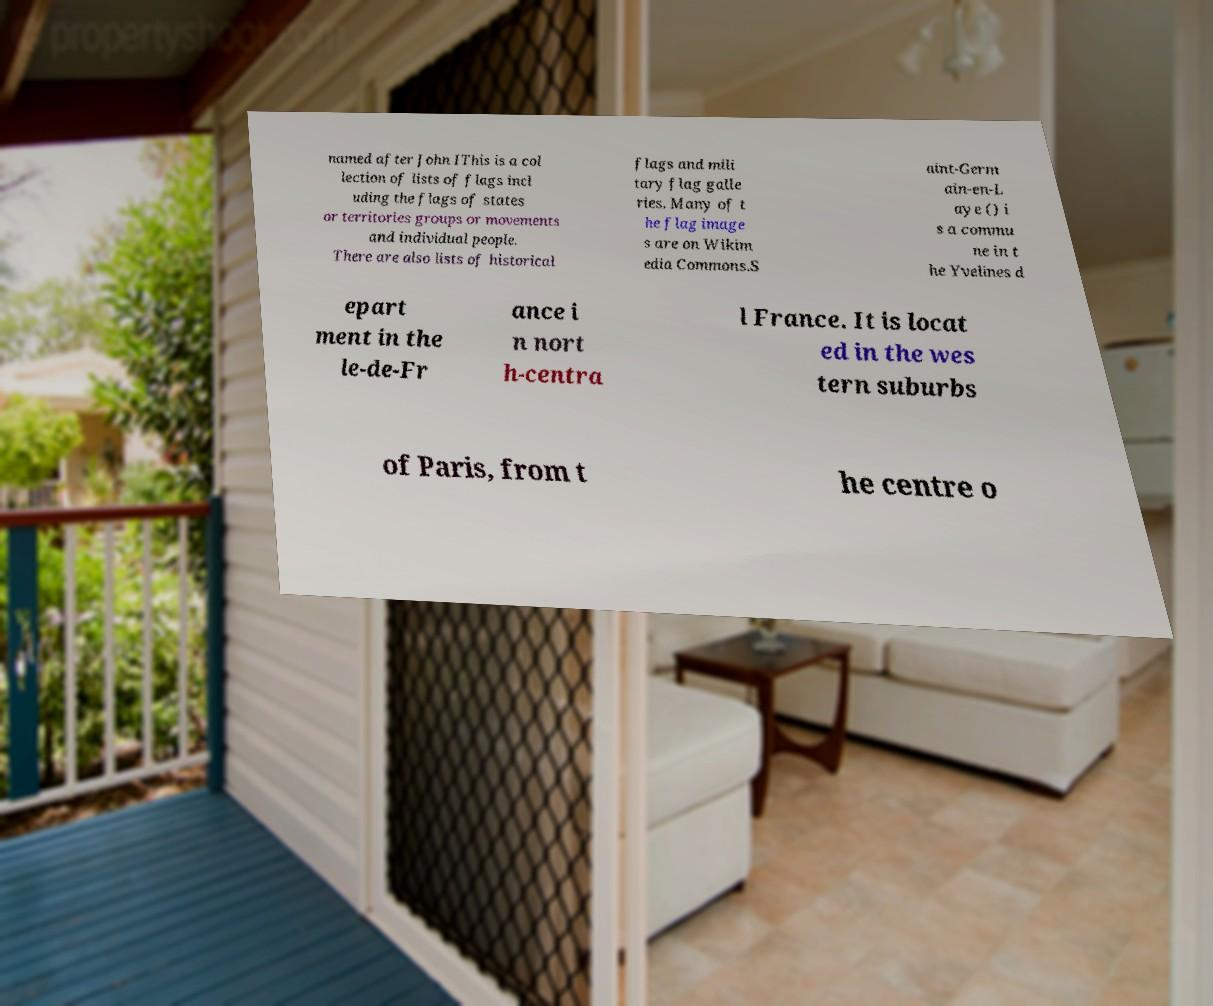For documentation purposes, I need the text within this image transcribed. Could you provide that? named after John IThis is a col lection of lists of flags incl uding the flags of states or territories groups or movements and individual people. There are also lists of historical flags and mili tary flag galle ries. Many of t he flag image s are on Wikim edia Commons.S aint-Germ ain-en-L aye () i s a commu ne in t he Yvelines d epart ment in the le-de-Fr ance i n nort h-centra l France. It is locat ed in the wes tern suburbs of Paris, from t he centre o 